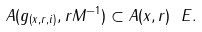<formula> <loc_0><loc_0><loc_500><loc_500>A ( g _ { ( x , r , i ) } , r M ^ { - 1 } ) \subset A ( x , r ) \ E .</formula> 